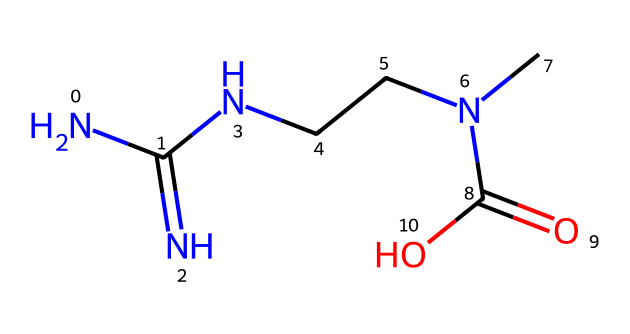How many nitrogen atoms are present in the structure? By examining the SMILES representation, we can identify the number of nitrogen atoms represented by "N". In this case, there are three instances of "N", indicating three nitrogen atoms in the chemical structure.
Answer: three What functional groups are present in creatine? The SMILES notation indicates the presence of a carboxylic acid group (C(=O)O) and an amidine group (NC(=N)N). The carboxylic acid is determined by the carbonyl (C=O) and hydroxyl (O) parts, while the amidine is recognized by the multiple nitrogen bonds.
Answer: carboxylic acid and amidine Which atom is directly attached to the carbon that is part of the carboxylic acid group? In the structure, the carbon in the carboxylic acid (C(=O)O) is also connected to a nitrogen atom and another carbon atom. Tracking the atoms shows the direct connection of the carboxylic acid carbon to another carbon atom (the one in NCC).
Answer: nitrogen and carbon Is creatine a simple hydrocarbon? Creatine contains nitrogen atoms and functional groups that are not characteristic of simple hydrocarbons, which are typically made up of only carbon and hydrogen atoms. Thus, it cannot be classified as a simple hydrocarbon.
Answer: no How many total atoms are in the creatine structure? Counting each atom from the given SMILES: there are 4 carbon (C), 3 nitrogen (N), and 4 hydrogen (H), and 2 oxygen (O) atoms. Adding these gives a total of 4 + 3 + 4 + 2 = 13 atoms in total.
Answer: thirteen What is the overall charge of creatine? In the given structure from the SMILES, there are no formal charges indicated on atoms, and the structure is neutral overall. This is determined by analyzing the typical valences of the atoms involved.
Answer: neutral 